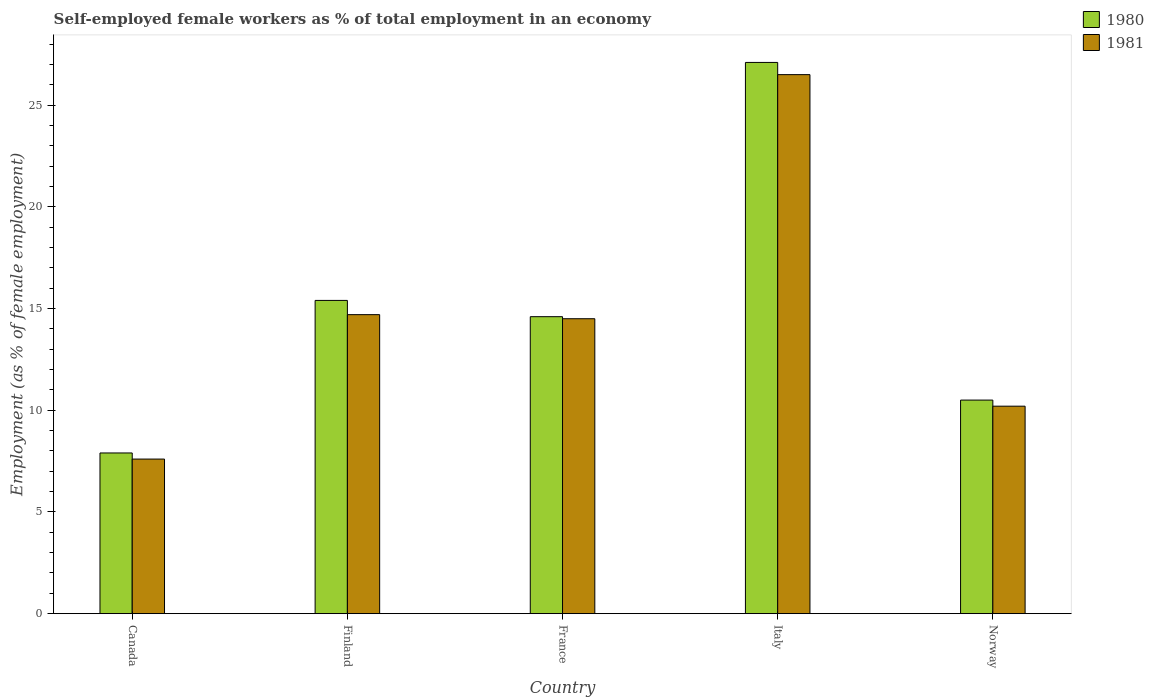Are the number of bars per tick equal to the number of legend labels?
Your response must be concise. Yes. How many bars are there on the 4th tick from the left?
Your response must be concise. 2. How many bars are there on the 5th tick from the right?
Ensure brevity in your answer.  2. What is the percentage of self-employed female workers in 1980 in Canada?
Offer a terse response. 7.9. Across all countries, what is the maximum percentage of self-employed female workers in 1980?
Ensure brevity in your answer.  27.1. Across all countries, what is the minimum percentage of self-employed female workers in 1981?
Ensure brevity in your answer.  7.6. In which country was the percentage of self-employed female workers in 1980 maximum?
Your response must be concise. Italy. What is the total percentage of self-employed female workers in 1981 in the graph?
Your response must be concise. 73.5. What is the difference between the percentage of self-employed female workers in 1980 in Canada and that in Italy?
Your answer should be compact. -19.2. What is the difference between the percentage of self-employed female workers in 1981 in France and the percentage of self-employed female workers in 1980 in Canada?
Provide a short and direct response. 6.6. What is the average percentage of self-employed female workers in 1981 per country?
Offer a very short reply. 14.7. What is the difference between the percentage of self-employed female workers of/in 1981 and percentage of self-employed female workers of/in 1980 in Canada?
Provide a succinct answer. -0.3. What is the ratio of the percentage of self-employed female workers in 1980 in Canada to that in Norway?
Your response must be concise. 0.75. What is the difference between the highest and the second highest percentage of self-employed female workers in 1981?
Offer a very short reply. 11.8. What is the difference between the highest and the lowest percentage of self-employed female workers in 1981?
Your answer should be compact. 18.9. Is the sum of the percentage of self-employed female workers in 1981 in Finland and France greater than the maximum percentage of self-employed female workers in 1980 across all countries?
Make the answer very short. Yes. What does the 1st bar from the left in Italy represents?
Ensure brevity in your answer.  1980. What is the difference between two consecutive major ticks on the Y-axis?
Provide a succinct answer. 5. Where does the legend appear in the graph?
Keep it short and to the point. Top right. How many legend labels are there?
Offer a very short reply. 2. What is the title of the graph?
Provide a short and direct response. Self-employed female workers as % of total employment in an economy. What is the label or title of the X-axis?
Ensure brevity in your answer.  Country. What is the label or title of the Y-axis?
Provide a short and direct response. Employment (as % of female employment). What is the Employment (as % of female employment) in 1980 in Canada?
Make the answer very short. 7.9. What is the Employment (as % of female employment) of 1981 in Canada?
Offer a terse response. 7.6. What is the Employment (as % of female employment) in 1980 in Finland?
Provide a short and direct response. 15.4. What is the Employment (as % of female employment) in 1981 in Finland?
Offer a terse response. 14.7. What is the Employment (as % of female employment) in 1980 in France?
Give a very brief answer. 14.6. What is the Employment (as % of female employment) in 1980 in Italy?
Keep it short and to the point. 27.1. What is the Employment (as % of female employment) of 1980 in Norway?
Keep it short and to the point. 10.5. What is the Employment (as % of female employment) of 1981 in Norway?
Give a very brief answer. 10.2. Across all countries, what is the maximum Employment (as % of female employment) of 1980?
Give a very brief answer. 27.1. Across all countries, what is the maximum Employment (as % of female employment) of 1981?
Give a very brief answer. 26.5. Across all countries, what is the minimum Employment (as % of female employment) in 1980?
Ensure brevity in your answer.  7.9. Across all countries, what is the minimum Employment (as % of female employment) of 1981?
Make the answer very short. 7.6. What is the total Employment (as % of female employment) of 1980 in the graph?
Provide a succinct answer. 75.5. What is the total Employment (as % of female employment) in 1981 in the graph?
Offer a very short reply. 73.5. What is the difference between the Employment (as % of female employment) of 1980 in Canada and that in Finland?
Your response must be concise. -7.5. What is the difference between the Employment (as % of female employment) of 1981 in Canada and that in Finland?
Make the answer very short. -7.1. What is the difference between the Employment (as % of female employment) in 1980 in Canada and that in France?
Make the answer very short. -6.7. What is the difference between the Employment (as % of female employment) of 1981 in Canada and that in France?
Give a very brief answer. -6.9. What is the difference between the Employment (as % of female employment) in 1980 in Canada and that in Italy?
Keep it short and to the point. -19.2. What is the difference between the Employment (as % of female employment) in 1981 in Canada and that in Italy?
Give a very brief answer. -18.9. What is the difference between the Employment (as % of female employment) in 1980 in Canada and that in Norway?
Make the answer very short. -2.6. What is the difference between the Employment (as % of female employment) in 1980 in Finland and that in France?
Offer a very short reply. 0.8. What is the difference between the Employment (as % of female employment) of 1980 in Finland and that in Italy?
Offer a terse response. -11.7. What is the difference between the Employment (as % of female employment) in 1981 in Finland and that in Italy?
Offer a terse response. -11.8. What is the difference between the Employment (as % of female employment) in 1980 in Finland and that in Norway?
Your answer should be compact. 4.9. What is the difference between the Employment (as % of female employment) of 1980 in France and that in Italy?
Offer a terse response. -12.5. What is the difference between the Employment (as % of female employment) in 1980 in France and that in Norway?
Keep it short and to the point. 4.1. What is the difference between the Employment (as % of female employment) in 1981 in France and that in Norway?
Provide a succinct answer. 4.3. What is the difference between the Employment (as % of female employment) of 1980 in Italy and that in Norway?
Make the answer very short. 16.6. What is the difference between the Employment (as % of female employment) of 1980 in Canada and the Employment (as % of female employment) of 1981 in France?
Your answer should be very brief. -6.6. What is the difference between the Employment (as % of female employment) in 1980 in Canada and the Employment (as % of female employment) in 1981 in Italy?
Provide a succinct answer. -18.6. What is the difference between the Employment (as % of female employment) in 1980 in Finland and the Employment (as % of female employment) in 1981 in Norway?
Give a very brief answer. 5.2. What is the difference between the Employment (as % of female employment) of 1980 in France and the Employment (as % of female employment) of 1981 in Italy?
Your answer should be compact. -11.9. What is the difference between the Employment (as % of female employment) of 1980 in France and the Employment (as % of female employment) of 1981 in Norway?
Offer a very short reply. 4.4. What is the average Employment (as % of female employment) in 1980 per country?
Your answer should be very brief. 15.1. What is the difference between the Employment (as % of female employment) of 1980 and Employment (as % of female employment) of 1981 in Canada?
Offer a very short reply. 0.3. What is the difference between the Employment (as % of female employment) of 1980 and Employment (as % of female employment) of 1981 in Finland?
Keep it short and to the point. 0.7. What is the difference between the Employment (as % of female employment) of 1980 and Employment (as % of female employment) of 1981 in France?
Ensure brevity in your answer.  0.1. What is the ratio of the Employment (as % of female employment) in 1980 in Canada to that in Finland?
Provide a short and direct response. 0.51. What is the ratio of the Employment (as % of female employment) of 1981 in Canada to that in Finland?
Provide a succinct answer. 0.52. What is the ratio of the Employment (as % of female employment) in 1980 in Canada to that in France?
Your answer should be very brief. 0.54. What is the ratio of the Employment (as % of female employment) in 1981 in Canada to that in France?
Make the answer very short. 0.52. What is the ratio of the Employment (as % of female employment) in 1980 in Canada to that in Italy?
Offer a terse response. 0.29. What is the ratio of the Employment (as % of female employment) of 1981 in Canada to that in Italy?
Make the answer very short. 0.29. What is the ratio of the Employment (as % of female employment) of 1980 in Canada to that in Norway?
Give a very brief answer. 0.75. What is the ratio of the Employment (as % of female employment) in 1981 in Canada to that in Norway?
Your answer should be very brief. 0.75. What is the ratio of the Employment (as % of female employment) of 1980 in Finland to that in France?
Make the answer very short. 1.05. What is the ratio of the Employment (as % of female employment) in 1981 in Finland to that in France?
Offer a very short reply. 1.01. What is the ratio of the Employment (as % of female employment) of 1980 in Finland to that in Italy?
Offer a very short reply. 0.57. What is the ratio of the Employment (as % of female employment) in 1981 in Finland to that in Italy?
Your answer should be very brief. 0.55. What is the ratio of the Employment (as % of female employment) of 1980 in Finland to that in Norway?
Provide a succinct answer. 1.47. What is the ratio of the Employment (as % of female employment) in 1981 in Finland to that in Norway?
Provide a short and direct response. 1.44. What is the ratio of the Employment (as % of female employment) in 1980 in France to that in Italy?
Make the answer very short. 0.54. What is the ratio of the Employment (as % of female employment) in 1981 in France to that in Italy?
Provide a short and direct response. 0.55. What is the ratio of the Employment (as % of female employment) of 1980 in France to that in Norway?
Provide a short and direct response. 1.39. What is the ratio of the Employment (as % of female employment) in 1981 in France to that in Norway?
Your response must be concise. 1.42. What is the ratio of the Employment (as % of female employment) in 1980 in Italy to that in Norway?
Your answer should be compact. 2.58. What is the ratio of the Employment (as % of female employment) of 1981 in Italy to that in Norway?
Make the answer very short. 2.6. What is the difference between the highest and the lowest Employment (as % of female employment) of 1981?
Your response must be concise. 18.9. 